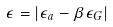Convert formula to latex. <formula><loc_0><loc_0><loc_500><loc_500>\epsilon = | \epsilon _ { a } - \beta \epsilon _ { G } |</formula> 